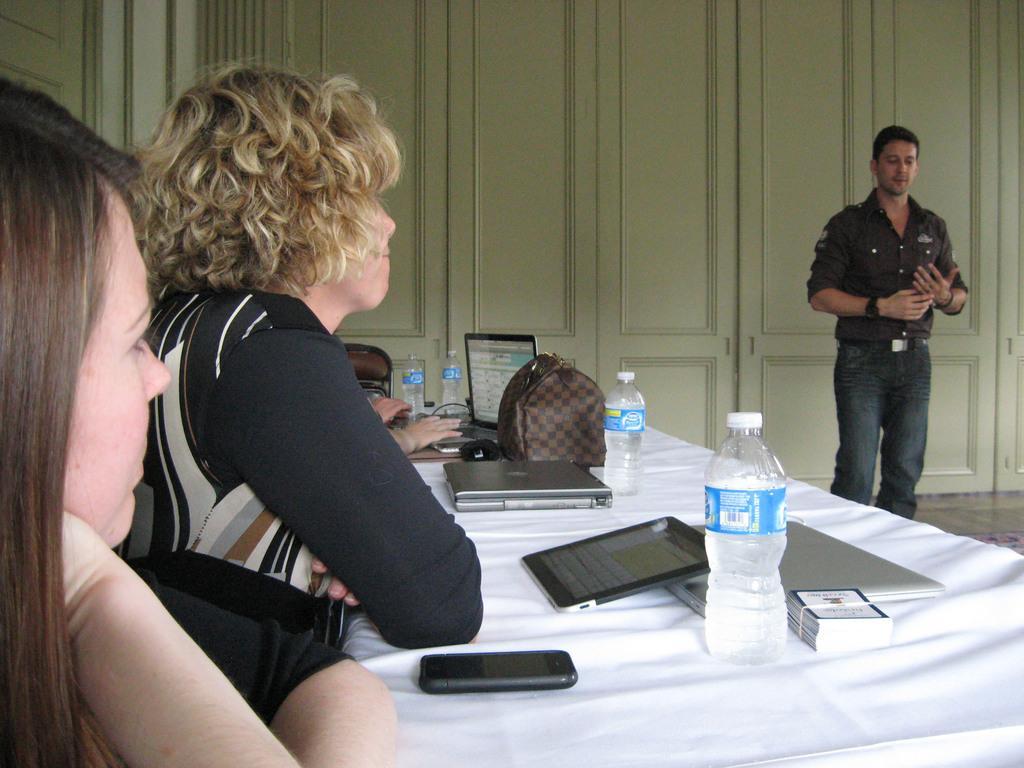How would you summarize this image in a sentence or two? To the left side of the image there are people sitting on a white table with electronic gadgets on top of it and to the right side of the image a guy is standing and explaining them. In the background we observe white color door. 